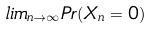<formula> <loc_0><loc_0><loc_500><loc_500>l i m _ { n \rightarrow \infty } P r ( X _ { n } = 0 )</formula> 